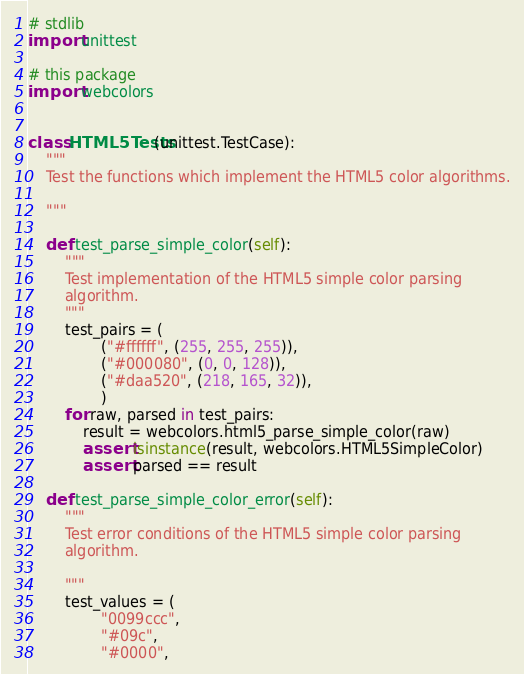<code> <loc_0><loc_0><loc_500><loc_500><_Python_># stdlib
import unittest

# this package
import webcolors


class HTML5Tests(unittest.TestCase):
	"""
	Test the functions which implement the HTML5 color algorithms.

	"""

	def test_parse_simple_color(self):
		"""
		Test implementation of the HTML5 simple color parsing
		algorithm.
		"""
		test_pairs = (
				("#ffffff", (255, 255, 255)),
				("#000080", (0, 0, 128)),
				("#daa520", (218, 165, 32)),
				)
		for raw, parsed in test_pairs:
			result = webcolors.html5_parse_simple_color(raw)
			assert isinstance(result, webcolors.HTML5SimpleColor)
			assert parsed == result

	def test_parse_simple_color_error(self):
		"""
		Test error conditions of the HTML5 simple color parsing
		algorithm.

		"""
		test_values = (
				"0099ccc",
				"#09c",
				"#0000",</code> 